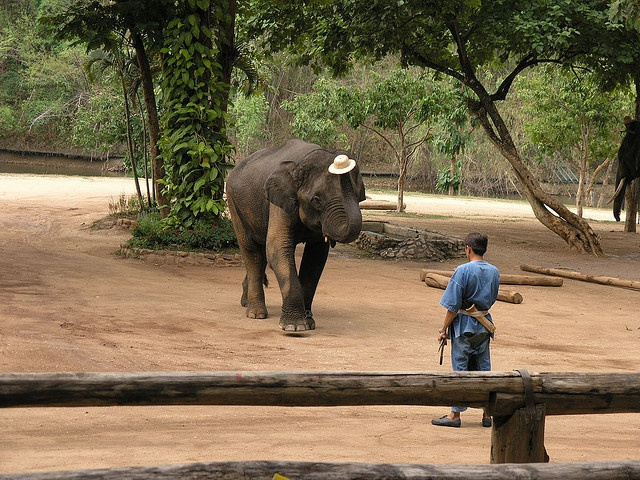Describe the objects in this image and their specific colors. I can see elephant in darkgreen, black, maroon, and gray tones and people in darkgreen, black, gray, and blue tones in this image. 